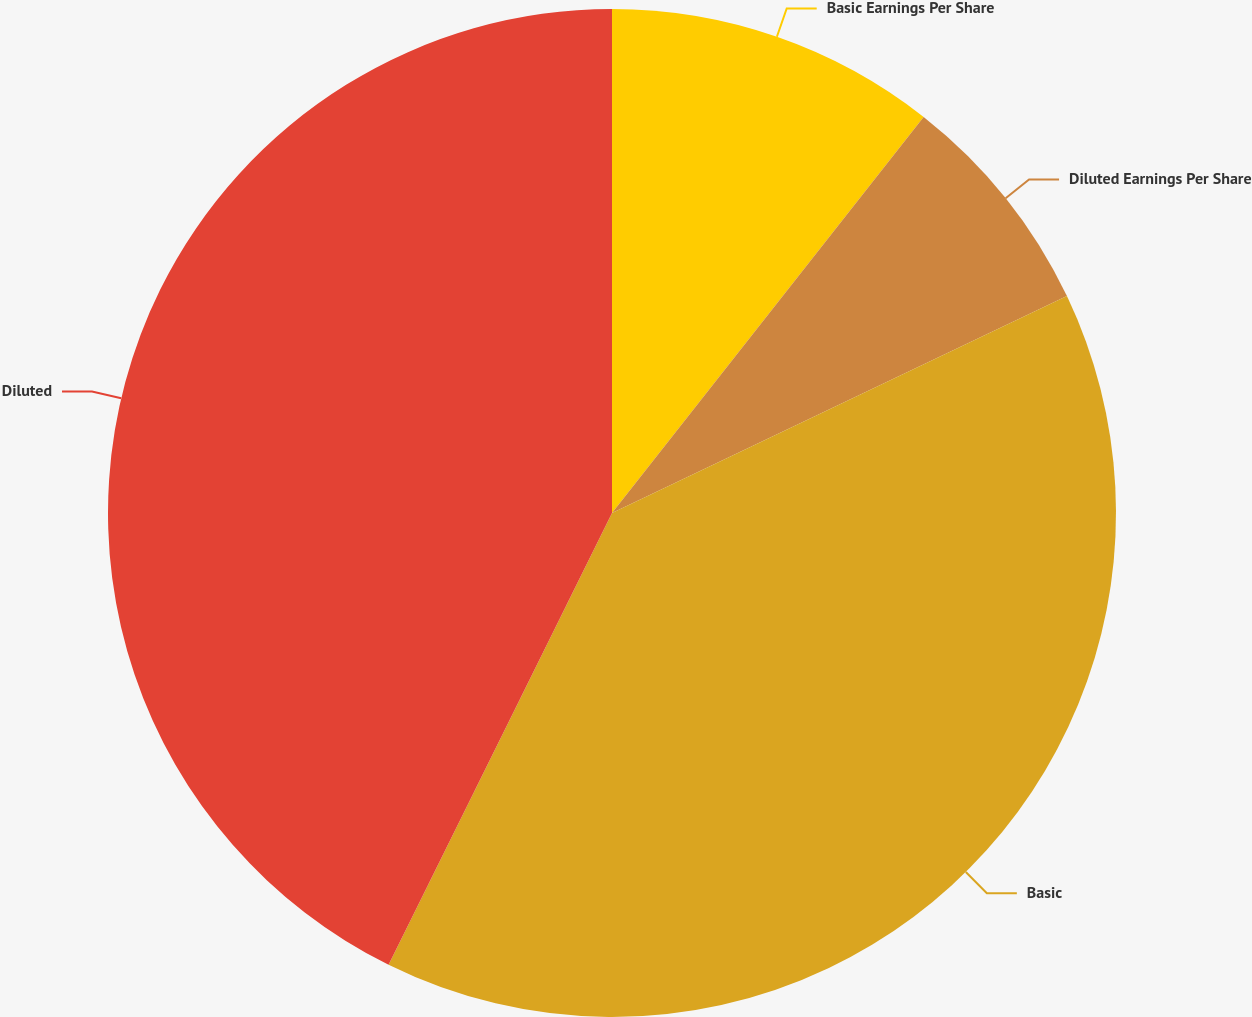Convert chart to OTSL. <chart><loc_0><loc_0><loc_500><loc_500><pie_chart><fcel>Basic Earnings Per Share<fcel>Diluted Earnings Per Share<fcel>Basic<fcel>Diluted<nl><fcel>10.61%<fcel>7.31%<fcel>39.39%<fcel>42.69%<nl></chart> 